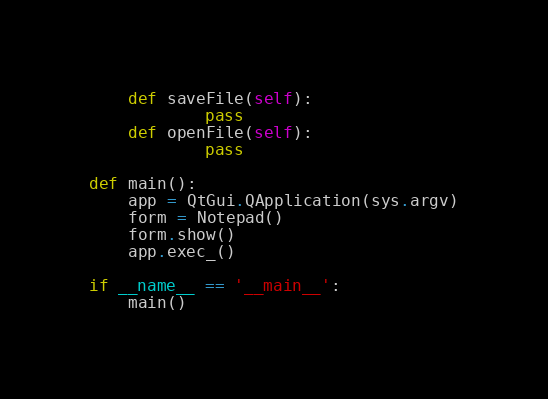<code> <loc_0><loc_0><loc_500><loc_500><_Python_>    def saveFile(self):
            pass
    def openFile(self):
            pass

def main():
    app = QtGui.QApplication(sys.argv)
    form = Notepad()
    form.show()
    app.exec_()

if __name__ == '__main__':
    main()</code> 